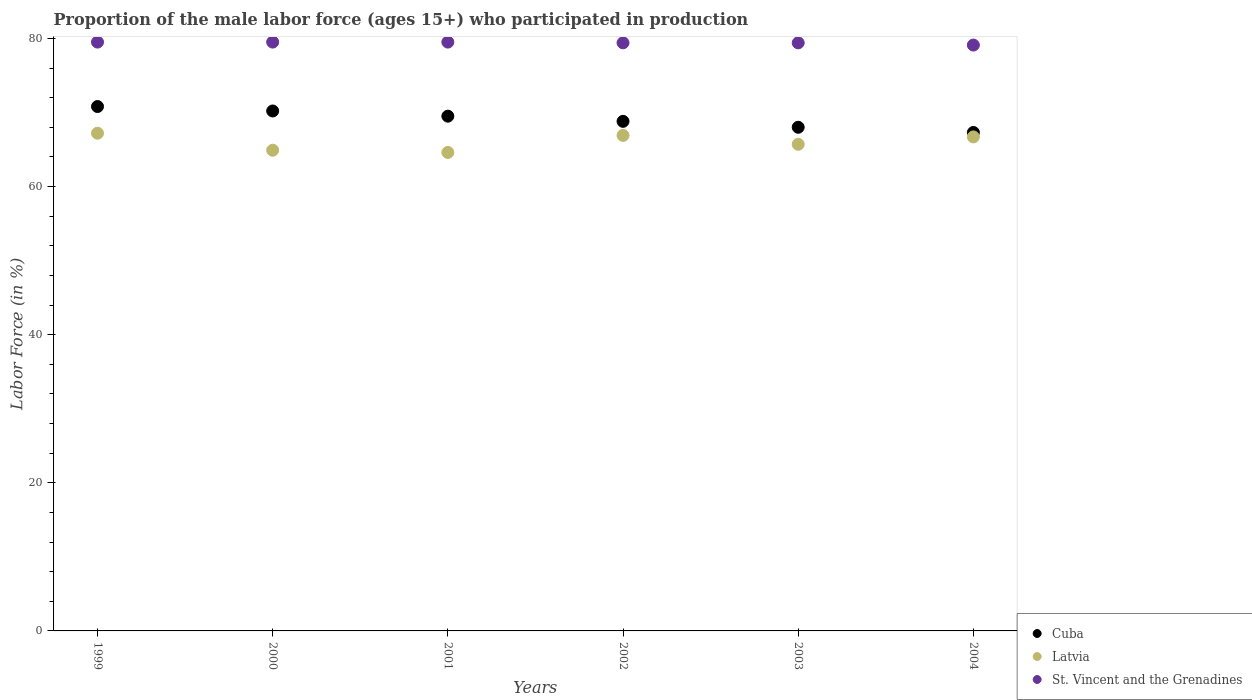What is the proportion of the male labor force who participated in production in Latvia in 2002?
Your answer should be compact. 66.9. Across all years, what is the maximum proportion of the male labor force who participated in production in Latvia?
Your answer should be compact. 67.2. Across all years, what is the minimum proportion of the male labor force who participated in production in Latvia?
Give a very brief answer. 64.6. What is the total proportion of the male labor force who participated in production in Cuba in the graph?
Your response must be concise. 414.6. What is the difference between the proportion of the male labor force who participated in production in St. Vincent and the Grenadines in 1999 and that in 2003?
Give a very brief answer. 0.1. What is the average proportion of the male labor force who participated in production in Cuba per year?
Your answer should be compact. 69.1. In the year 2002, what is the difference between the proportion of the male labor force who participated in production in Cuba and proportion of the male labor force who participated in production in Latvia?
Your answer should be compact. 1.9. In how many years, is the proportion of the male labor force who participated in production in Cuba greater than 28 %?
Ensure brevity in your answer.  6. What is the ratio of the proportion of the male labor force who participated in production in Latvia in 2000 to that in 2001?
Offer a very short reply. 1. What is the difference between the highest and the second highest proportion of the male labor force who participated in production in St. Vincent and the Grenadines?
Provide a short and direct response. 0. What is the difference between the highest and the lowest proportion of the male labor force who participated in production in St. Vincent and the Grenadines?
Keep it short and to the point. 0.4. Is the sum of the proportion of the male labor force who participated in production in Cuba in 2000 and 2001 greater than the maximum proportion of the male labor force who participated in production in St. Vincent and the Grenadines across all years?
Give a very brief answer. Yes. Does the proportion of the male labor force who participated in production in Cuba monotonically increase over the years?
Offer a very short reply. No. Does the graph contain any zero values?
Your answer should be very brief. No. Where does the legend appear in the graph?
Your answer should be compact. Bottom right. How many legend labels are there?
Give a very brief answer. 3. What is the title of the graph?
Your answer should be compact. Proportion of the male labor force (ages 15+) who participated in production. What is the label or title of the X-axis?
Offer a terse response. Years. What is the Labor Force (in %) of Cuba in 1999?
Provide a short and direct response. 70.8. What is the Labor Force (in %) of Latvia in 1999?
Give a very brief answer. 67.2. What is the Labor Force (in %) of St. Vincent and the Grenadines in 1999?
Offer a terse response. 79.5. What is the Labor Force (in %) of Cuba in 2000?
Your answer should be very brief. 70.2. What is the Labor Force (in %) in Latvia in 2000?
Provide a succinct answer. 64.9. What is the Labor Force (in %) in St. Vincent and the Grenadines in 2000?
Provide a succinct answer. 79.5. What is the Labor Force (in %) of Cuba in 2001?
Offer a very short reply. 69.5. What is the Labor Force (in %) of Latvia in 2001?
Your answer should be compact. 64.6. What is the Labor Force (in %) of St. Vincent and the Grenadines in 2001?
Ensure brevity in your answer.  79.5. What is the Labor Force (in %) of Cuba in 2002?
Keep it short and to the point. 68.8. What is the Labor Force (in %) in Latvia in 2002?
Ensure brevity in your answer.  66.9. What is the Labor Force (in %) of St. Vincent and the Grenadines in 2002?
Provide a succinct answer. 79.4. What is the Labor Force (in %) in Cuba in 2003?
Make the answer very short. 68. What is the Labor Force (in %) of Latvia in 2003?
Your answer should be compact. 65.7. What is the Labor Force (in %) of St. Vincent and the Grenadines in 2003?
Your response must be concise. 79.4. What is the Labor Force (in %) of Cuba in 2004?
Give a very brief answer. 67.3. What is the Labor Force (in %) in Latvia in 2004?
Give a very brief answer. 66.7. What is the Labor Force (in %) in St. Vincent and the Grenadines in 2004?
Make the answer very short. 79.1. Across all years, what is the maximum Labor Force (in %) in Cuba?
Make the answer very short. 70.8. Across all years, what is the maximum Labor Force (in %) in Latvia?
Your answer should be compact. 67.2. Across all years, what is the maximum Labor Force (in %) in St. Vincent and the Grenadines?
Provide a short and direct response. 79.5. Across all years, what is the minimum Labor Force (in %) in Cuba?
Provide a short and direct response. 67.3. Across all years, what is the minimum Labor Force (in %) in Latvia?
Your response must be concise. 64.6. Across all years, what is the minimum Labor Force (in %) of St. Vincent and the Grenadines?
Provide a short and direct response. 79.1. What is the total Labor Force (in %) of Cuba in the graph?
Make the answer very short. 414.6. What is the total Labor Force (in %) in Latvia in the graph?
Your answer should be compact. 396. What is the total Labor Force (in %) of St. Vincent and the Grenadines in the graph?
Provide a succinct answer. 476.4. What is the difference between the Labor Force (in %) in St. Vincent and the Grenadines in 1999 and that in 2000?
Your answer should be compact. 0. What is the difference between the Labor Force (in %) of St. Vincent and the Grenadines in 1999 and that in 2002?
Your answer should be very brief. 0.1. What is the difference between the Labor Force (in %) in Cuba in 1999 and that in 2003?
Your response must be concise. 2.8. What is the difference between the Labor Force (in %) of Cuba in 1999 and that in 2004?
Offer a very short reply. 3.5. What is the difference between the Labor Force (in %) of Latvia in 1999 and that in 2004?
Your response must be concise. 0.5. What is the difference between the Labor Force (in %) of Latvia in 2000 and that in 2001?
Your answer should be compact. 0.3. What is the difference between the Labor Force (in %) of St. Vincent and the Grenadines in 2000 and that in 2001?
Provide a succinct answer. 0. What is the difference between the Labor Force (in %) of St. Vincent and the Grenadines in 2000 and that in 2002?
Provide a succinct answer. 0.1. What is the difference between the Labor Force (in %) in Cuba in 2000 and that in 2003?
Make the answer very short. 2.2. What is the difference between the Labor Force (in %) of St. Vincent and the Grenadines in 2000 and that in 2003?
Your answer should be very brief. 0.1. What is the difference between the Labor Force (in %) of Latvia in 2000 and that in 2004?
Your answer should be very brief. -1.8. What is the difference between the Labor Force (in %) in St. Vincent and the Grenadines in 2000 and that in 2004?
Provide a succinct answer. 0.4. What is the difference between the Labor Force (in %) of Latvia in 2001 and that in 2002?
Provide a short and direct response. -2.3. What is the difference between the Labor Force (in %) in Latvia in 2001 and that in 2003?
Give a very brief answer. -1.1. What is the difference between the Labor Force (in %) of St. Vincent and the Grenadines in 2001 and that in 2004?
Your response must be concise. 0.4. What is the difference between the Labor Force (in %) of Latvia in 2002 and that in 2003?
Provide a succinct answer. 1.2. What is the difference between the Labor Force (in %) in St. Vincent and the Grenadines in 2002 and that in 2003?
Offer a terse response. 0. What is the difference between the Labor Force (in %) in Cuba in 2002 and that in 2004?
Your answer should be very brief. 1.5. What is the difference between the Labor Force (in %) of Latvia in 2002 and that in 2004?
Make the answer very short. 0.2. What is the difference between the Labor Force (in %) in St. Vincent and the Grenadines in 2002 and that in 2004?
Provide a short and direct response. 0.3. What is the difference between the Labor Force (in %) in Cuba in 1999 and the Labor Force (in %) in St. Vincent and the Grenadines in 2000?
Give a very brief answer. -8.7. What is the difference between the Labor Force (in %) of Latvia in 1999 and the Labor Force (in %) of St. Vincent and the Grenadines in 2001?
Give a very brief answer. -12.3. What is the difference between the Labor Force (in %) in Cuba in 1999 and the Labor Force (in %) in St. Vincent and the Grenadines in 2002?
Offer a terse response. -8.6. What is the difference between the Labor Force (in %) in Cuba in 1999 and the Labor Force (in %) in Latvia in 2003?
Provide a succinct answer. 5.1. What is the difference between the Labor Force (in %) in Cuba in 1999 and the Labor Force (in %) in St. Vincent and the Grenadines in 2003?
Your answer should be compact. -8.6. What is the difference between the Labor Force (in %) of Cuba in 1999 and the Labor Force (in %) of Latvia in 2004?
Provide a succinct answer. 4.1. What is the difference between the Labor Force (in %) in Cuba in 1999 and the Labor Force (in %) in St. Vincent and the Grenadines in 2004?
Provide a short and direct response. -8.3. What is the difference between the Labor Force (in %) in Cuba in 2000 and the Labor Force (in %) in Latvia in 2001?
Your answer should be compact. 5.6. What is the difference between the Labor Force (in %) of Latvia in 2000 and the Labor Force (in %) of St. Vincent and the Grenadines in 2001?
Offer a very short reply. -14.6. What is the difference between the Labor Force (in %) in Cuba in 2000 and the Labor Force (in %) in St. Vincent and the Grenadines in 2002?
Provide a short and direct response. -9.2. What is the difference between the Labor Force (in %) in Latvia in 2000 and the Labor Force (in %) in St. Vincent and the Grenadines in 2002?
Provide a succinct answer. -14.5. What is the difference between the Labor Force (in %) of Cuba in 2000 and the Labor Force (in %) of Latvia in 2003?
Provide a short and direct response. 4.5. What is the difference between the Labor Force (in %) of Cuba in 2000 and the Labor Force (in %) of St. Vincent and the Grenadines in 2003?
Ensure brevity in your answer.  -9.2. What is the difference between the Labor Force (in %) of Latvia in 2000 and the Labor Force (in %) of St. Vincent and the Grenadines in 2003?
Keep it short and to the point. -14.5. What is the difference between the Labor Force (in %) in Cuba in 2001 and the Labor Force (in %) in St. Vincent and the Grenadines in 2002?
Your answer should be compact. -9.9. What is the difference between the Labor Force (in %) of Latvia in 2001 and the Labor Force (in %) of St. Vincent and the Grenadines in 2002?
Your answer should be compact. -14.8. What is the difference between the Labor Force (in %) of Cuba in 2001 and the Labor Force (in %) of Latvia in 2003?
Keep it short and to the point. 3.8. What is the difference between the Labor Force (in %) in Cuba in 2001 and the Labor Force (in %) in St. Vincent and the Grenadines in 2003?
Make the answer very short. -9.9. What is the difference between the Labor Force (in %) of Latvia in 2001 and the Labor Force (in %) of St. Vincent and the Grenadines in 2003?
Keep it short and to the point. -14.8. What is the difference between the Labor Force (in %) in Cuba in 2001 and the Labor Force (in %) in Latvia in 2004?
Your response must be concise. 2.8. What is the difference between the Labor Force (in %) of Cuba in 2002 and the Labor Force (in %) of Latvia in 2004?
Provide a succinct answer. 2.1. What is the difference between the Labor Force (in %) of Cuba in 2002 and the Labor Force (in %) of St. Vincent and the Grenadines in 2004?
Your answer should be very brief. -10.3. What is the difference between the Labor Force (in %) in Latvia in 2002 and the Labor Force (in %) in St. Vincent and the Grenadines in 2004?
Make the answer very short. -12.2. What is the difference between the Labor Force (in %) of Cuba in 2003 and the Labor Force (in %) of Latvia in 2004?
Your answer should be very brief. 1.3. What is the difference between the Labor Force (in %) of Latvia in 2003 and the Labor Force (in %) of St. Vincent and the Grenadines in 2004?
Ensure brevity in your answer.  -13.4. What is the average Labor Force (in %) of Cuba per year?
Your response must be concise. 69.1. What is the average Labor Force (in %) of St. Vincent and the Grenadines per year?
Offer a very short reply. 79.4. In the year 1999, what is the difference between the Labor Force (in %) of Cuba and Labor Force (in %) of Latvia?
Your response must be concise. 3.6. In the year 1999, what is the difference between the Labor Force (in %) of Latvia and Labor Force (in %) of St. Vincent and the Grenadines?
Offer a terse response. -12.3. In the year 2000, what is the difference between the Labor Force (in %) of Cuba and Labor Force (in %) of Latvia?
Offer a terse response. 5.3. In the year 2000, what is the difference between the Labor Force (in %) of Latvia and Labor Force (in %) of St. Vincent and the Grenadines?
Offer a very short reply. -14.6. In the year 2001, what is the difference between the Labor Force (in %) in Latvia and Labor Force (in %) in St. Vincent and the Grenadines?
Give a very brief answer. -14.9. In the year 2002, what is the difference between the Labor Force (in %) of Latvia and Labor Force (in %) of St. Vincent and the Grenadines?
Your answer should be very brief. -12.5. In the year 2003, what is the difference between the Labor Force (in %) of Cuba and Labor Force (in %) of Latvia?
Your answer should be very brief. 2.3. In the year 2003, what is the difference between the Labor Force (in %) in Cuba and Labor Force (in %) in St. Vincent and the Grenadines?
Your response must be concise. -11.4. In the year 2003, what is the difference between the Labor Force (in %) in Latvia and Labor Force (in %) in St. Vincent and the Grenadines?
Make the answer very short. -13.7. In the year 2004, what is the difference between the Labor Force (in %) in Cuba and Labor Force (in %) in Latvia?
Offer a very short reply. 0.6. In the year 2004, what is the difference between the Labor Force (in %) in Cuba and Labor Force (in %) in St. Vincent and the Grenadines?
Provide a succinct answer. -11.8. In the year 2004, what is the difference between the Labor Force (in %) in Latvia and Labor Force (in %) in St. Vincent and the Grenadines?
Keep it short and to the point. -12.4. What is the ratio of the Labor Force (in %) in Cuba in 1999 to that in 2000?
Offer a terse response. 1.01. What is the ratio of the Labor Force (in %) in Latvia in 1999 to that in 2000?
Offer a very short reply. 1.04. What is the ratio of the Labor Force (in %) in Cuba in 1999 to that in 2001?
Provide a succinct answer. 1.02. What is the ratio of the Labor Force (in %) of Latvia in 1999 to that in 2001?
Offer a very short reply. 1.04. What is the ratio of the Labor Force (in %) of St. Vincent and the Grenadines in 1999 to that in 2001?
Ensure brevity in your answer.  1. What is the ratio of the Labor Force (in %) in Cuba in 1999 to that in 2002?
Keep it short and to the point. 1.03. What is the ratio of the Labor Force (in %) of St. Vincent and the Grenadines in 1999 to that in 2002?
Your answer should be very brief. 1. What is the ratio of the Labor Force (in %) of Cuba in 1999 to that in 2003?
Your answer should be very brief. 1.04. What is the ratio of the Labor Force (in %) of Latvia in 1999 to that in 2003?
Provide a succinct answer. 1.02. What is the ratio of the Labor Force (in %) in Cuba in 1999 to that in 2004?
Provide a succinct answer. 1.05. What is the ratio of the Labor Force (in %) in Latvia in 1999 to that in 2004?
Offer a very short reply. 1.01. What is the ratio of the Labor Force (in %) of Cuba in 2000 to that in 2002?
Give a very brief answer. 1.02. What is the ratio of the Labor Force (in %) of Latvia in 2000 to that in 2002?
Give a very brief answer. 0.97. What is the ratio of the Labor Force (in %) of Cuba in 2000 to that in 2003?
Offer a very short reply. 1.03. What is the ratio of the Labor Force (in %) in Latvia in 2000 to that in 2003?
Your answer should be compact. 0.99. What is the ratio of the Labor Force (in %) in St. Vincent and the Grenadines in 2000 to that in 2003?
Make the answer very short. 1. What is the ratio of the Labor Force (in %) in Cuba in 2000 to that in 2004?
Give a very brief answer. 1.04. What is the ratio of the Labor Force (in %) in Cuba in 2001 to that in 2002?
Offer a very short reply. 1.01. What is the ratio of the Labor Force (in %) in Latvia in 2001 to that in 2002?
Give a very brief answer. 0.97. What is the ratio of the Labor Force (in %) in St. Vincent and the Grenadines in 2001 to that in 2002?
Your response must be concise. 1. What is the ratio of the Labor Force (in %) in Cuba in 2001 to that in 2003?
Provide a short and direct response. 1.02. What is the ratio of the Labor Force (in %) of Latvia in 2001 to that in 2003?
Provide a short and direct response. 0.98. What is the ratio of the Labor Force (in %) of Cuba in 2001 to that in 2004?
Give a very brief answer. 1.03. What is the ratio of the Labor Force (in %) of Latvia in 2001 to that in 2004?
Ensure brevity in your answer.  0.97. What is the ratio of the Labor Force (in %) in St. Vincent and the Grenadines in 2001 to that in 2004?
Offer a terse response. 1.01. What is the ratio of the Labor Force (in %) in Cuba in 2002 to that in 2003?
Provide a succinct answer. 1.01. What is the ratio of the Labor Force (in %) in Latvia in 2002 to that in 2003?
Give a very brief answer. 1.02. What is the ratio of the Labor Force (in %) in St. Vincent and the Grenadines in 2002 to that in 2003?
Your answer should be very brief. 1. What is the ratio of the Labor Force (in %) of Cuba in 2002 to that in 2004?
Keep it short and to the point. 1.02. What is the ratio of the Labor Force (in %) in Cuba in 2003 to that in 2004?
Offer a very short reply. 1.01. What is the difference between the highest and the second highest Labor Force (in %) in Latvia?
Give a very brief answer. 0.3. What is the difference between the highest and the lowest Labor Force (in %) in Cuba?
Keep it short and to the point. 3.5. What is the difference between the highest and the lowest Labor Force (in %) of Latvia?
Your answer should be very brief. 2.6. What is the difference between the highest and the lowest Labor Force (in %) in St. Vincent and the Grenadines?
Keep it short and to the point. 0.4. 